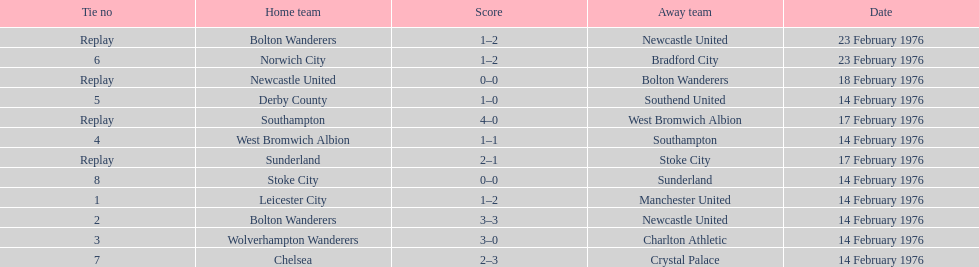Who had a better score, manchester united or wolverhampton wanderers? Wolverhampton Wanderers. 